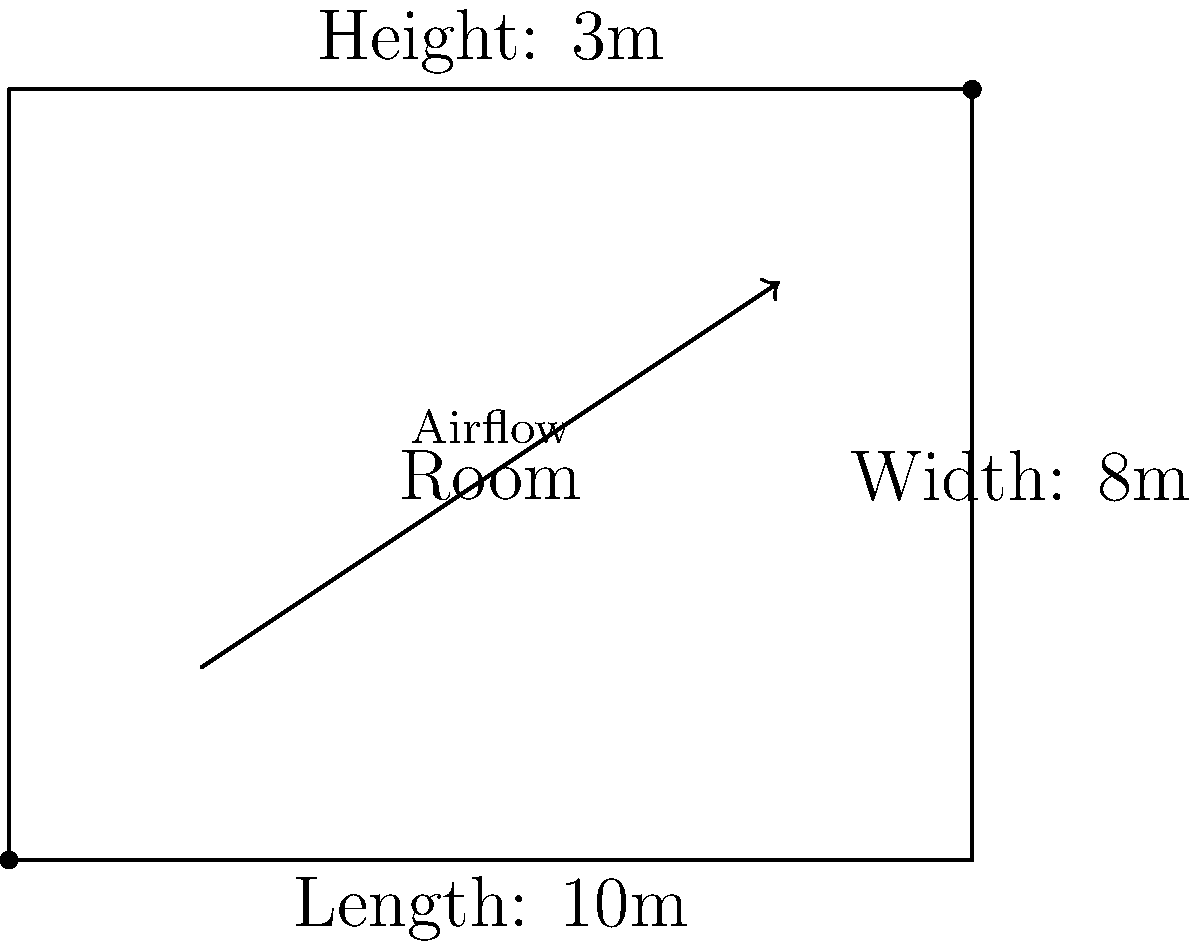As an interior designer collaborating with a real estate agent, you need to ensure optimal comfort in a newly designed room. Given a room with dimensions 10m x 8m x 3m (length x width x height) and a desired temperature change of 5°C, calculate the required airflow rate in cubic meters per hour (m³/h) for the HVAC system. Assume an air density of 1.2 kg/m³, specific heat capacity of air as 1000 J/(kg·°C), and that 80% of the cooling capacity is used for sensible cooling. The cooling load of the room is estimated to be 2500 W. To calculate the optimal airflow rate for the HVAC system, we'll follow these steps:

1. Calculate the room volume:
   $V = 10 \text{ m} \times 8 \text{ m} \times 3 \text{ m} = 240 \text{ m}^3$

2. Determine the sensible cooling load:
   $Q_s = 0.8 \times 2500 \text{ W} = 2000 \text{ W}$

3. Use the sensible heat equation:
   $Q_s = \dot{m} \times c_p \times \Delta T$
   
   Where:
   $Q_s$ = Sensible cooling load (W)
   $\dot{m}$ = Mass flow rate of air (kg/s)
   $c_p$ = Specific heat capacity of air (J/(kg·°C))
   $\Delta T$ = Temperature difference (°C)

4. Rearrange the equation to solve for mass flow rate:
   $\dot{m} = \frac{Q_s}{c_p \times \Delta T}$

5. Substitute the values:
   $\dot{m} = \frac{2000 \text{ W}}{1000 \text{ J/(kg·°C)} \times 5 \text{ °C}} = 0.4 \text{ kg/s}$

6. Convert mass flow rate to volumetric flow rate:
   $\dot{V} = \frac{\dot{m}}{\rho}$
   
   Where:
   $\dot{V}$ = Volumetric flow rate (m³/s)
   $\rho$ = Air density (kg/m³)

7. Calculate the volumetric flow rate:
   $\dot{V} = \frac{0.4 \text{ kg/s}}{1.2 \text{ kg/m}^3} = 0.333 \text{ m}^3/\text{s}$

8. Convert to cubic meters per hour:
   $\dot{V} = 0.333 \text{ m}^3/\text{s} \times 3600 \text{ s/h} = 1200 \text{ m}^3/\text{h}$

Therefore, the required airflow rate for the HVAC system is 1200 m³/h.
Answer: 1200 m³/h 